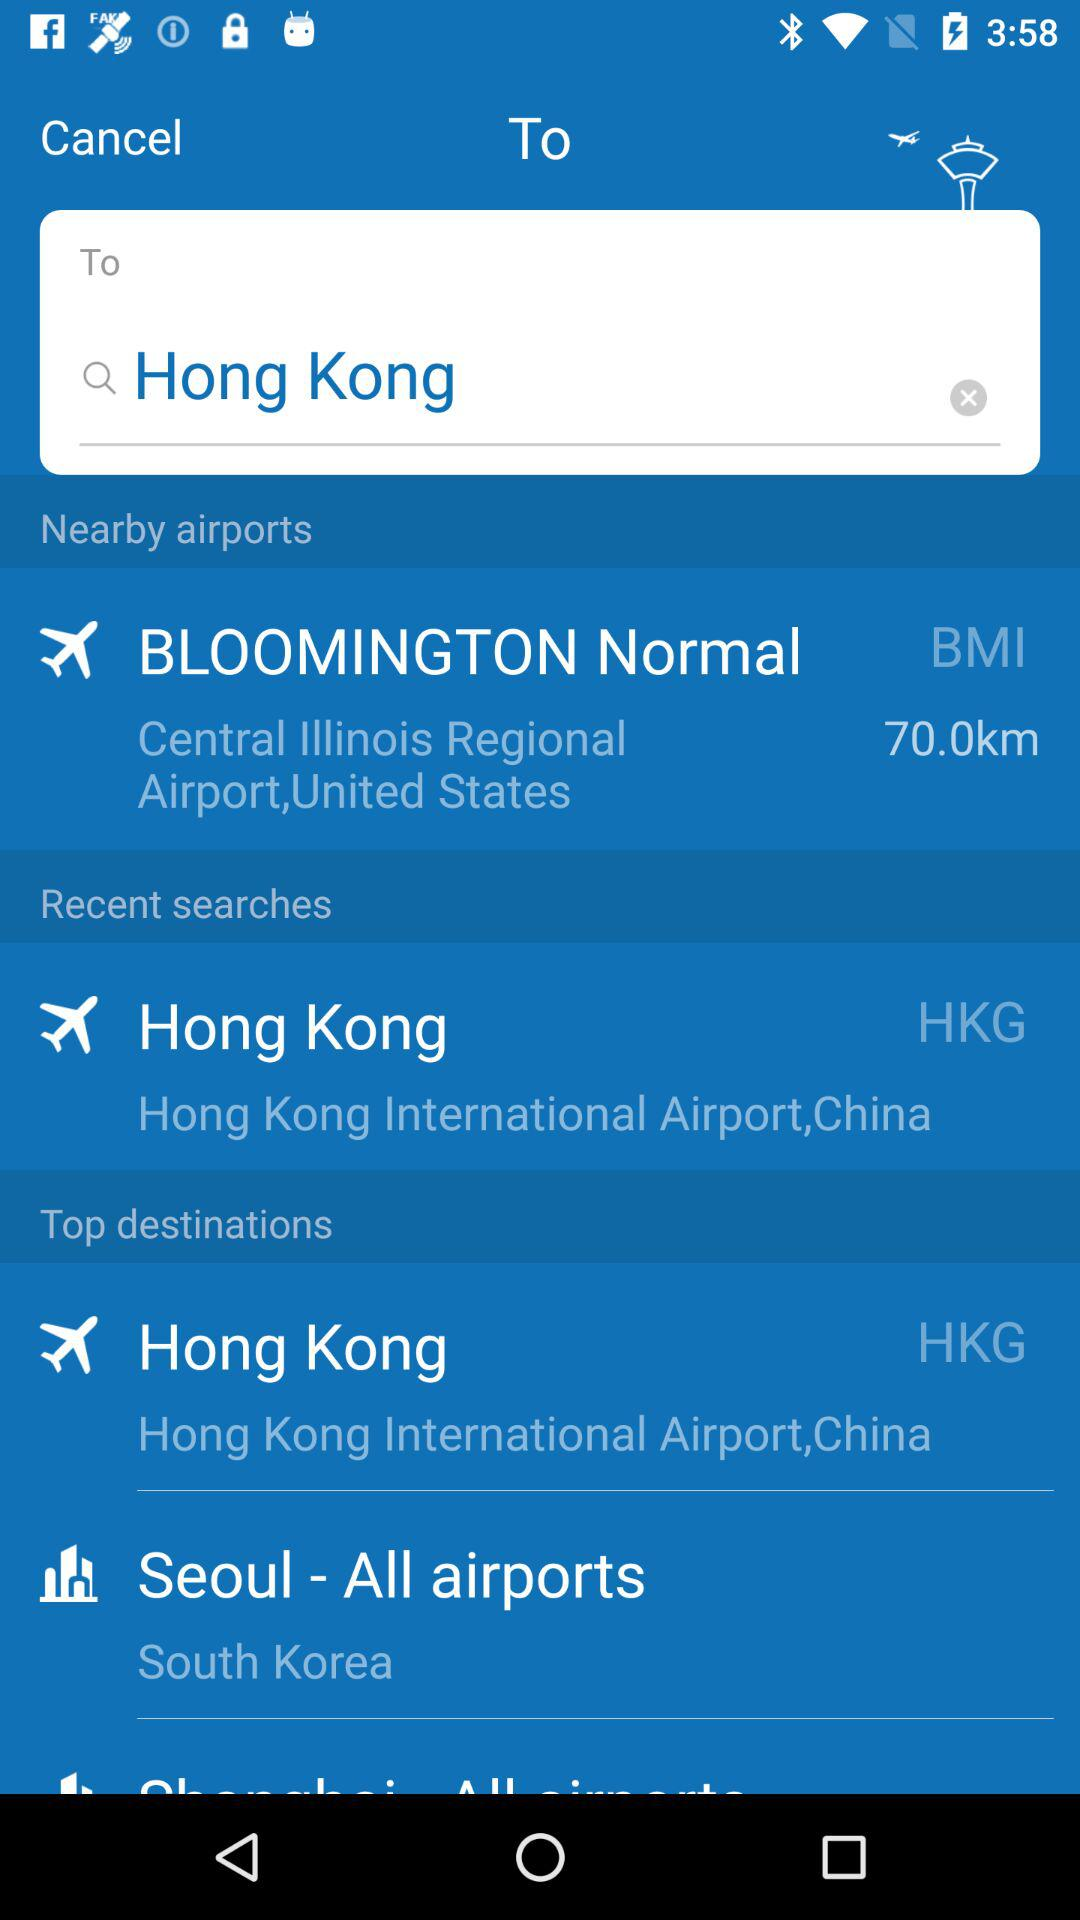What are the recent searches? The recent search is Hong Kong. 